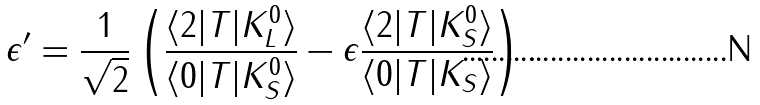<formula> <loc_0><loc_0><loc_500><loc_500>\epsilon ^ { \prime } = \frac { 1 } { \sqrt { 2 } } \left ( \frac { \langle 2 | T | K ^ { 0 } _ { L } \rangle } { \langle 0 | T | K ^ { 0 } _ { S } \rangle } - \epsilon \frac { \langle 2 | T | K ^ { 0 } _ { S } \rangle } { \langle 0 | T | K _ { S } \rangle } \right ) .</formula> 